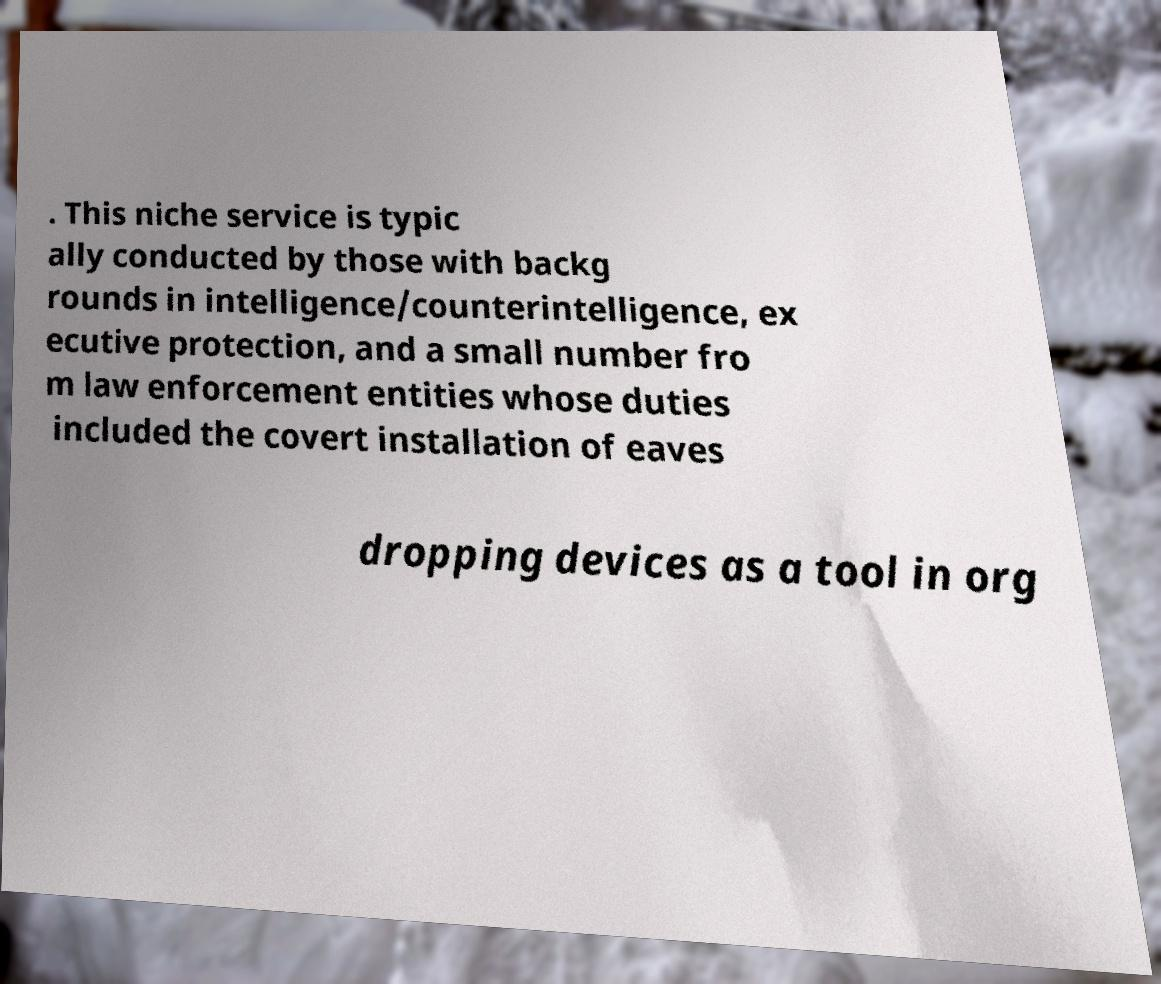Could you extract and type out the text from this image? . This niche service is typic ally conducted by those with backg rounds in intelligence/counterintelligence, ex ecutive protection, and a small number fro m law enforcement entities whose duties included the covert installation of eaves dropping devices as a tool in org 